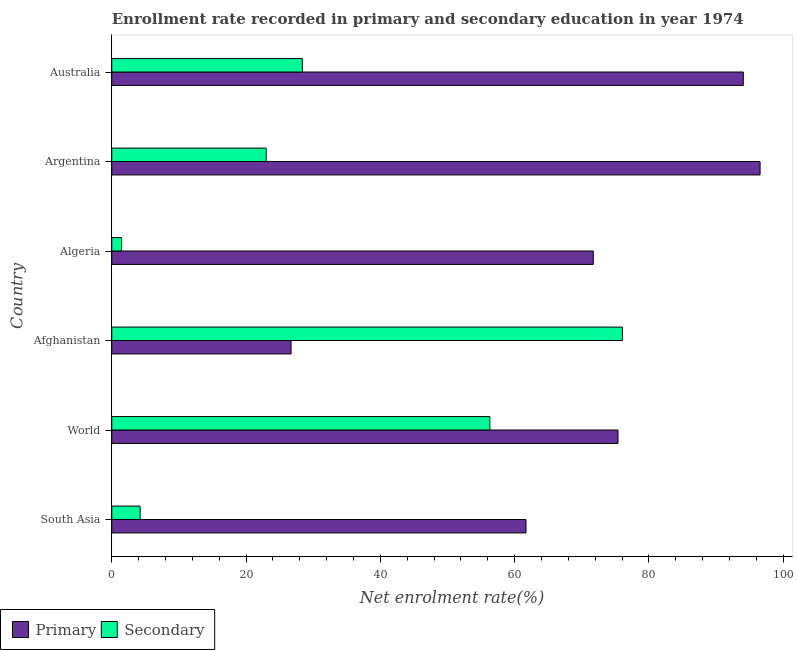Are the number of bars on each tick of the Y-axis equal?
Offer a terse response. Yes. How many bars are there on the 1st tick from the top?
Keep it short and to the point. 2. How many bars are there on the 6th tick from the bottom?
Make the answer very short. 2. What is the label of the 3rd group of bars from the top?
Your response must be concise. Algeria. In how many cases, is the number of bars for a given country not equal to the number of legend labels?
Give a very brief answer. 0. What is the enrollment rate in secondary education in World?
Your answer should be very brief. 56.3. Across all countries, what is the maximum enrollment rate in secondary education?
Your answer should be compact. 76.05. Across all countries, what is the minimum enrollment rate in secondary education?
Your answer should be very brief. 1.47. In which country was the enrollment rate in primary education minimum?
Make the answer very short. Afghanistan. What is the total enrollment rate in primary education in the graph?
Make the answer very short. 426.1. What is the difference between the enrollment rate in primary education in Afghanistan and that in World?
Provide a succinct answer. -48.69. What is the difference between the enrollment rate in secondary education in South Asia and the enrollment rate in primary education in Australia?
Your answer should be compact. -89.83. What is the average enrollment rate in secondary education per country?
Provide a succinct answer. 31.57. What is the difference between the enrollment rate in secondary education and enrollment rate in primary education in World?
Provide a short and direct response. -19.09. In how many countries, is the enrollment rate in secondary education greater than 52 %?
Make the answer very short. 2. What is the ratio of the enrollment rate in secondary education in Afghanistan to that in Argentina?
Provide a short and direct response. 3.31. What is the difference between the highest and the second highest enrollment rate in primary education?
Your response must be concise. 2.5. What is the difference between the highest and the lowest enrollment rate in primary education?
Your answer should be compact. 69.85. In how many countries, is the enrollment rate in secondary education greater than the average enrollment rate in secondary education taken over all countries?
Your answer should be very brief. 2. Is the sum of the enrollment rate in secondary education in Australia and World greater than the maximum enrollment rate in primary education across all countries?
Your response must be concise. No. What does the 1st bar from the top in Australia represents?
Your answer should be compact. Secondary. What does the 2nd bar from the bottom in Afghanistan represents?
Ensure brevity in your answer.  Secondary. How many bars are there?
Make the answer very short. 12. Are all the bars in the graph horizontal?
Provide a succinct answer. Yes. Are the values on the major ticks of X-axis written in scientific E-notation?
Provide a succinct answer. No. Does the graph contain any zero values?
Give a very brief answer. No. Where does the legend appear in the graph?
Provide a short and direct response. Bottom left. How are the legend labels stacked?
Give a very brief answer. Horizontal. What is the title of the graph?
Offer a very short reply. Enrollment rate recorded in primary and secondary education in year 1974. Does "current US$" appear as one of the legend labels in the graph?
Your response must be concise. No. What is the label or title of the X-axis?
Give a very brief answer. Net enrolment rate(%). What is the Net enrolment rate(%) in Primary in South Asia?
Your response must be concise. 61.69. What is the Net enrolment rate(%) in Secondary in South Asia?
Offer a terse response. 4.22. What is the Net enrolment rate(%) in Primary in World?
Your answer should be compact. 75.39. What is the Net enrolment rate(%) in Secondary in World?
Keep it short and to the point. 56.3. What is the Net enrolment rate(%) of Primary in Afghanistan?
Your response must be concise. 26.7. What is the Net enrolment rate(%) in Secondary in Afghanistan?
Offer a very short reply. 76.05. What is the Net enrolment rate(%) of Primary in Algeria?
Keep it short and to the point. 71.71. What is the Net enrolment rate(%) in Secondary in Algeria?
Your answer should be very brief. 1.47. What is the Net enrolment rate(%) of Primary in Argentina?
Ensure brevity in your answer.  96.55. What is the Net enrolment rate(%) of Secondary in Argentina?
Your answer should be compact. 22.99. What is the Net enrolment rate(%) of Primary in Australia?
Keep it short and to the point. 94.05. What is the Net enrolment rate(%) in Secondary in Australia?
Keep it short and to the point. 28.38. Across all countries, what is the maximum Net enrolment rate(%) in Primary?
Offer a very short reply. 96.55. Across all countries, what is the maximum Net enrolment rate(%) in Secondary?
Provide a succinct answer. 76.05. Across all countries, what is the minimum Net enrolment rate(%) of Primary?
Provide a succinct answer. 26.7. Across all countries, what is the minimum Net enrolment rate(%) in Secondary?
Ensure brevity in your answer.  1.47. What is the total Net enrolment rate(%) of Primary in the graph?
Your answer should be very brief. 426.1. What is the total Net enrolment rate(%) of Secondary in the graph?
Provide a short and direct response. 189.42. What is the difference between the Net enrolment rate(%) of Primary in South Asia and that in World?
Offer a very short reply. -13.7. What is the difference between the Net enrolment rate(%) of Secondary in South Asia and that in World?
Your answer should be compact. -52.08. What is the difference between the Net enrolment rate(%) of Primary in South Asia and that in Afghanistan?
Your answer should be compact. 34.99. What is the difference between the Net enrolment rate(%) of Secondary in South Asia and that in Afghanistan?
Provide a succinct answer. -71.83. What is the difference between the Net enrolment rate(%) of Primary in South Asia and that in Algeria?
Your answer should be very brief. -10.02. What is the difference between the Net enrolment rate(%) of Secondary in South Asia and that in Algeria?
Keep it short and to the point. 2.76. What is the difference between the Net enrolment rate(%) of Primary in South Asia and that in Argentina?
Offer a terse response. -34.86. What is the difference between the Net enrolment rate(%) of Secondary in South Asia and that in Argentina?
Your answer should be very brief. -18.77. What is the difference between the Net enrolment rate(%) of Primary in South Asia and that in Australia?
Ensure brevity in your answer.  -32.37. What is the difference between the Net enrolment rate(%) in Secondary in South Asia and that in Australia?
Make the answer very short. -24.16. What is the difference between the Net enrolment rate(%) of Primary in World and that in Afghanistan?
Give a very brief answer. 48.69. What is the difference between the Net enrolment rate(%) of Secondary in World and that in Afghanistan?
Your response must be concise. -19.75. What is the difference between the Net enrolment rate(%) in Primary in World and that in Algeria?
Your response must be concise. 3.68. What is the difference between the Net enrolment rate(%) of Secondary in World and that in Algeria?
Provide a succinct answer. 54.84. What is the difference between the Net enrolment rate(%) in Primary in World and that in Argentina?
Keep it short and to the point. -21.16. What is the difference between the Net enrolment rate(%) in Secondary in World and that in Argentina?
Offer a very short reply. 33.31. What is the difference between the Net enrolment rate(%) of Primary in World and that in Australia?
Your response must be concise. -18.66. What is the difference between the Net enrolment rate(%) in Secondary in World and that in Australia?
Provide a short and direct response. 27.92. What is the difference between the Net enrolment rate(%) of Primary in Afghanistan and that in Algeria?
Offer a very short reply. -45.01. What is the difference between the Net enrolment rate(%) of Secondary in Afghanistan and that in Algeria?
Provide a short and direct response. 74.58. What is the difference between the Net enrolment rate(%) in Primary in Afghanistan and that in Argentina?
Your answer should be very brief. -69.85. What is the difference between the Net enrolment rate(%) of Secondary in Afghanistan and that in Argentina?
Offer a terse response. 53.06. What is the difference between the Net enrolment rate(%) in Primary in Afghanistan and that in Australia?
Provide a succinct answer. -67.35. What is the difference between the Net enrolment rate(%) in Secondary in Afghanistan and that in Australia?
Provide a succinct answer. 47.66. What is the difference between the Net enrolment rate(%) of Primary in Algeria and that in Argentina?
Provide a short and direct response. -24.84. What is the difference between the Net enrolment rate(%) of Secondary in Algeria and that in Argentina?
Provide a short and direct response. -21.53. What is the difference between the Net enrolment rate(%) of Primary in Algeria and that in Australia?
Keep it short and to the point. -22.34. What is the difference between the Net enrolment rate(%) in Secondary in Algeria and that in Australia?
Your answer should be very brief. -26.92. What is the difference between the Net enrolment rate(%) of Primary in Argentina and that in Australia?
Provide a short and direct response. 2.5. What is the difference between the Net enrolment rate(%) of Secondary in Argentina and that in Australia?
Your answer should be compact. -5.39. What is the difference between the Net enrolment rate(%) in Primary in South Asia and the Net enrolment rate(%) in Secondary in World?
Provide a succinct answer. 5.38. What is the difference between the Net enrolment rate(%) in Primary in South Asia and the Net enrolment rate(%) in Secondary in Afghanistan?
Keep it short and to the point. -14.36. What is the difference between the Net enrolment rate(%) of Primary in South Asia and the Net enrolment rate(%) of Secondary in Algeria?
Keep it short and to the point. 60.22. What is the difference between the Net enrolment rate(%) of Primary in South Asia and the Net enrolment rate(%) of Secondary in Argentina?
Offer a terse response. 38.7. What is the difference between the Net enrolment rate(%) in Primary in South Asia and the Net enrolment rate(%) in Secondary in Australia?
Offer a very short reply. 33.3. What is the difference between the Net enrolment rate(%) in Primary in World and the Net enrolment rate(%) in Secondary in Afghanistan?
Your answer should be very brief. -0.66. What is the difference between the Net enrolment rate(%) of Primary in World and the Net enrolment rate(%) of Secondary in Algeria?
Your answer should be very brief. 73.92. What is the difference between the Net enrolment rate(%) of Primary in World and the Net enrolment rate(%) of Secondary in Argentina?
Provide a succinct answer. 52.4. What is the difference between the Net enrolment rate(%) in Primary in World and the Net enrolment rate(%) in Secondary in Australia?
Your answer should be very brief. 47.01. What is the difference between the Net enrolment rate(%) in Primary in Afghanistan and the Net enrolment rate(%) in Secondary in Algeria?
Offer a terse response. 25.23. What is the difference between the Net enrolment rate(%) in Primary in Afghanistan and the Net enrolment rate(%) in Secondary in Argentina?
Keep it short and to the point. 3.71. What is the difference between the Net enrolment rate(%) of Primary in Afghanistan and the Net enrolment rate(%) of Secondary in Australia?
Ensure brevity in your answer.  -1.68. What is the difference between the Net enrolment rate(%) in Primary in Algeria and the Net enrolment rate(%) in Secondary in Argentina?
Make the answer very short. 48.72. What is the difference between the Net enrolment rate(%) of Primary in Algeria and the Net enrolment rate(%) of Secondary in Australia?
Keep it short and to the point. 43.33. What is the difference between the Net enrolment rate(%) in Primary in Argentina and the Net enrolment rate(%) in Secondary in Australia?
Keep it short and to the point. 68.17. What is the average Net enrolment rate(%) of Primary per country?
Provide a succinct answer. 71.02. What is the average Net enrolment rate(%) in Secondary per country?
Give a very brief answer. 31.57. What is the difference between the Net enrolment rate(%) in Primary and Net enrolment rate(%) in Secondary in South Asia?
Your response must be concise. 57.47. What is the difference between the Net enrolment rate(%) of Primary and Net enrolment rate(%) of Secondary in World?
Offer a terse response. 19.09. What is the difference between the Net enrolment rate(%) in Primary and Net enrolment rate(%) in Secondary in Afghanistan?
Your answer should be very brief. -49.35. What is the difference between the Net enrolment rate(%) in Primary and Net enrolment rate(%) in Secondary in Algeria?
Offer a very short reply. 70.24. What is the difference between the Net enrolment rate(%) of Primary and Net enrolment rate(%) of Secondary in Argentina?
Ensure brevity in your answer.  73.56. What is the difference between the Net enrolment rate(%) of Primary and Net enrolment rate(%) of Secondary in Australia?
Your response must be concise. 65.67. What is the ratio of the Net enrolment rate(%) in Primary in South Asia to that in World?
Provide a succinct answer. 0.82. What is the ratio of the Net enrolment rate(%) of Secondary in South Asia to that in World?
Ensure brevity in your answer.  0.07. What is the ratio of the Net enrolment rate(%) of Primary in South Asia to that in Afghanistan?
Provide a succinct answer. 2.31. What is the ratio of the Net enrolment rate(%) of Secondary in South Asia to that in Afghanistan?
Keep it short and to the point. 0.06. What is the ratio of the Net enrolment rate(%) of Primary in South Asia to that in Algeria?
Offer a very short reply. 0.86. What is the ratio of the Net enrolment rate(%) of Secondary in South Asia to that in Algeria?
Offer a terse response. 2.88. What is the ratio of the Net enrolment rate(%) of Primary in South Asia to that in Argentina?
Provide a short and direct response. 0.64. What is the ratio of the Net enrolment rate(%) in Secondary in South Asia to that in Argentina?
Your answer should be very brief. 0.18. What is the ratio of the Net enrolment rate(%) in Primary in South Asia to that in Australia?
Your answer should be compact. 0.66. What is the ratio of the Net enrolment rate(%) in Secondary in South Asia to that in Australia?
Offer a terse response. 0.15. What is the ratio of the Net enrolment rate(%) of Primary in World to that in Afghanistan?
Provide a short and direct response. 2.82. What is the ratio of the Net enrolment rate(%) of Secondary in World to that in Afghanistan?
Make the answer very short. 0.74. What is the ratio of the Net enrolment rate(%) in Primary in World to that in Algeria?
Give a very brief answer. 1.05. What is the ratio of the Net enrolment rate(%) in Secondary in World to that in Algeria?
Make the answer very short. 38.4. What is the ratio of the Net enrolment rate(%) of Primary in World to that in Argentina?
Your response must be concise. 0.78. What is the ratio of the Net enrolment rate(%) in Secondary in World to that in Argentina?
Your answer should be compact. 2.45. What is the ratio of the Net enrolment rate(%) of Primary in World to that in Australia?
Keep it short and to the point. 0.8. What is the ratio of the Net enrolment rate(%) of Secondary in World to that in Australia?
Your answer should be compact. 1.98. What is the ratio of the Net enrolment rate(%) in Primary in Afghanistan to that in Algeria?
Offer a terse response. 0.37. What is the ratio of the Net enrolment rate(%) in Secondary in Afghanistan to that in Algeria?
Your answer should be very brief. 51.87. What is the ratio of the Net enrolment rate(%) in Primary in Afghanistan to that in Argentina?
Provide a short and direct response. 0.28. What is the ratio of the Net enrolment rate(%) of Secondary in Afghanistan to that in Argentina?
Provide a short and direct response. 3.31. What is the ratio of the Net enrolment rate(%) in Primary in Afghanistan to that in Australia?
Make the answer very short. 0.28. What is the ratio of the Net enrolment rate(%) of Secondary in Afghanistan to that in Australia?
Your answer should be compact. 2.68. What is the ratio of the Net enrolment rate(%) of Primary in Algeria to that in Argentina?
Your answer should be compact. 0.74. What is the ratio of the Net enrolment rate(%) in Secondary in Algeria to that in Argentina?
Your answer should be very brief. 0.06. What is the ratio of the Net enrolment rate(%) of Primary in Algeria to that in Australia?
Offer a very short reply. 0.76. What is the ratio of the Net enrolment rate(%) of Secondary in Algeria to that in Australia?
Keep it short and to the point. 0.05. What is the ratio of the Net enrolment rate(%) of Primary in Argentina to that in Australia?
Give a very brief answer. 1.03. What is the ratio of the Net enrolment rate(%) in Secondary in Argentina to that in Australia?
Your response must be concise. 0.81. What is the difference between the highest and the second highest Net enrolment rate(%) in Primary?
Make the answer very short. 2.5. What is the difference between the highest and the second highest Net enrolment rate(%) of Secondary?
Your response must be concise. 19.75. What is the difference between the highest and the lowest Net enrolment rate(%) of Primary?
Your answer should be very brief. 69.85. What is the difference between the highest and the lowest Net enrolment rate(%) in Secondary?
Give a very brief answer. 74.58. 